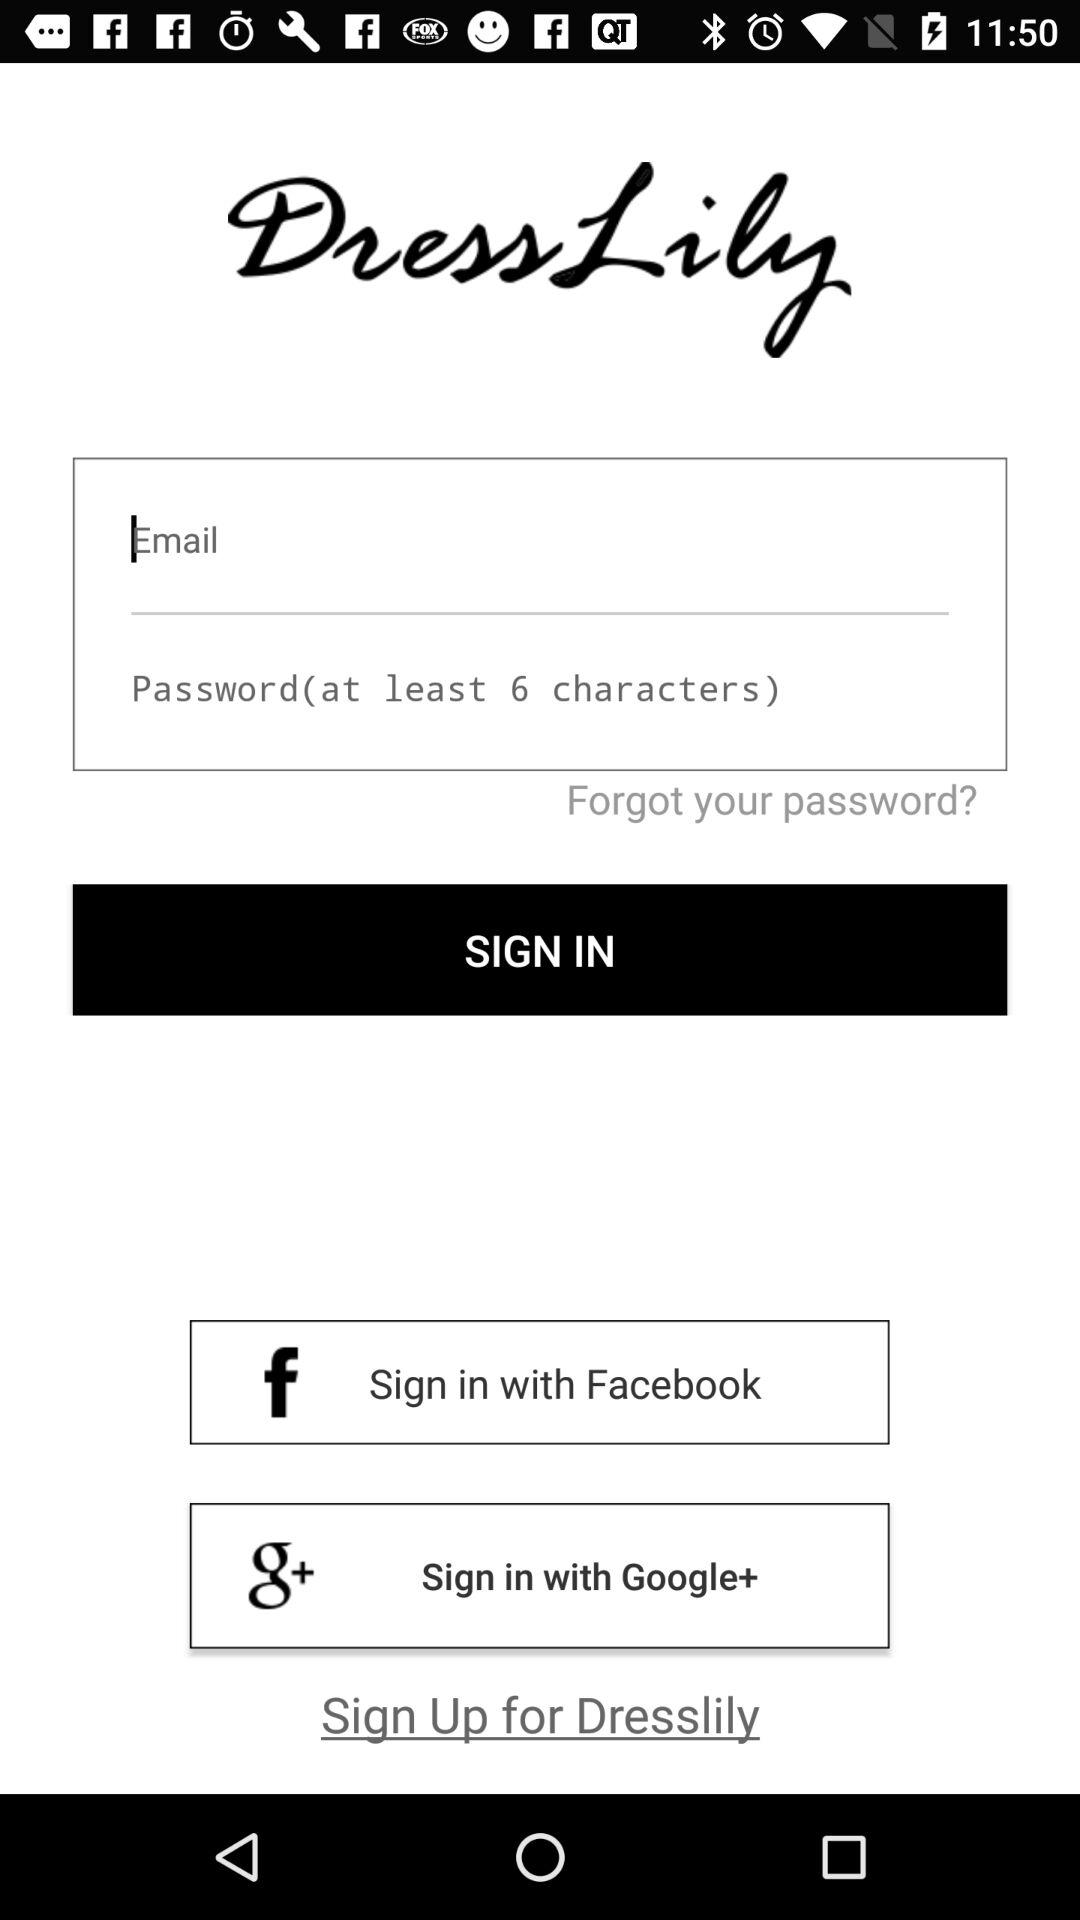Which social apps can we sign in to? The social apps you can sign in with are "Facebook" and "Google". 